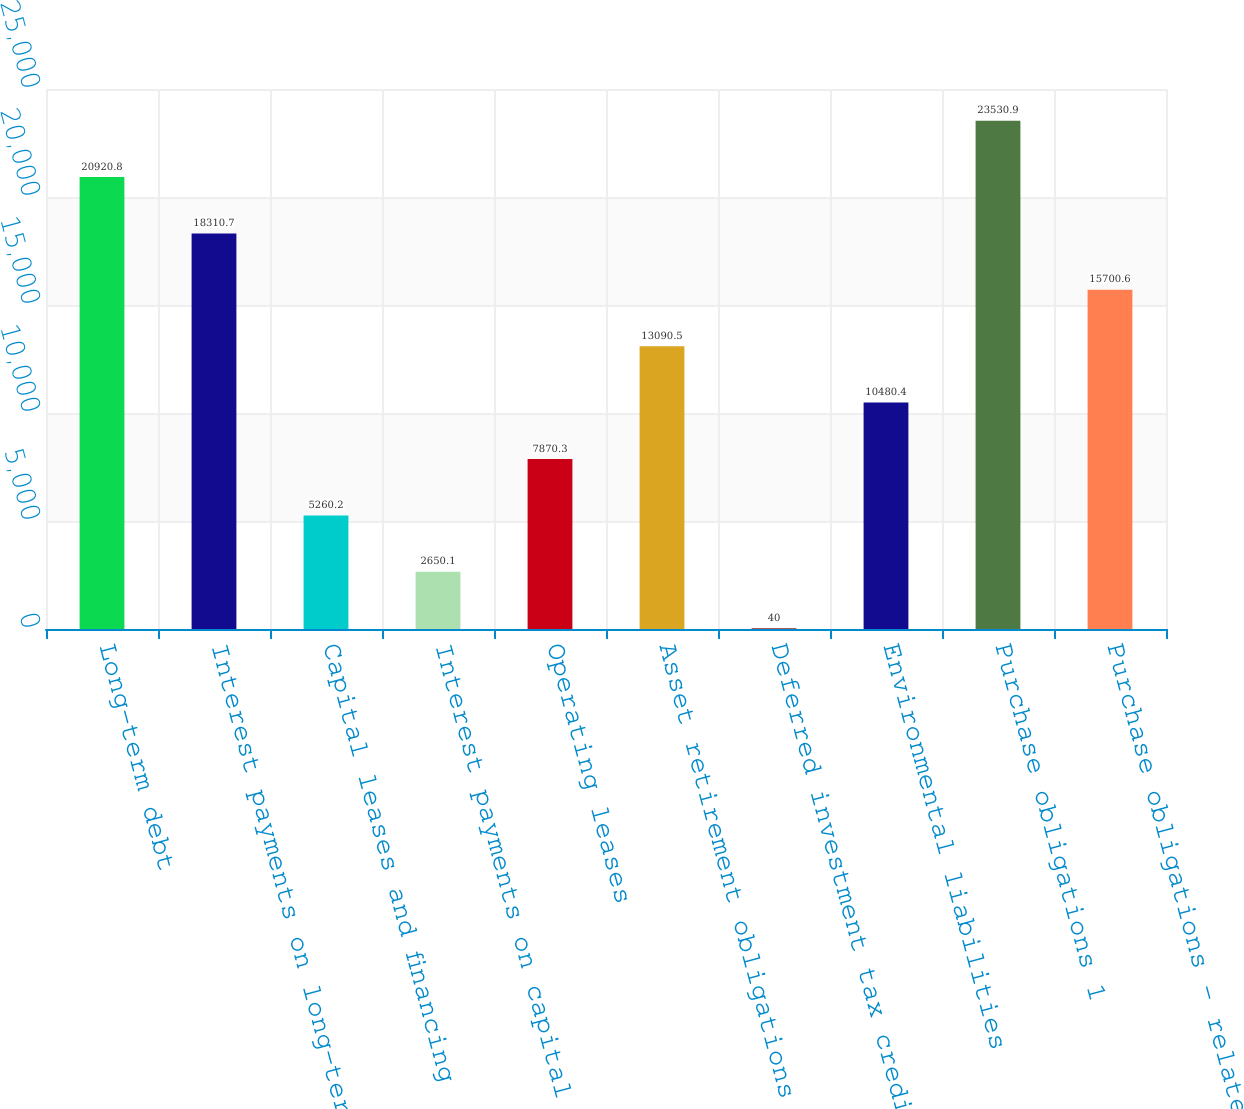Convert chart. <chart><loc_0><loc_0><loc_500><loc_500><bar_chart><fcel>Long-term debt<fcel>Interest payments on long-term<fcel>Capital leases and financing<fcel>Interest payments on capital<fcel>Operating leases<fcel>Asset retirement obligations<fcel>Deferred investment tax credit<fcel>Environmental liabilities<fcel>Purchase obligations 1<fcel>Purchase obligations - related<nl><fcel>20920.8<fcel>18310.7<fcel>5260.2<fcel>2650.1<fcel>7870.3<fcel>13090.5<fcel>40<fcel>10480.4<fcel>23530.9<fcel>15700.6<nl></chart> 